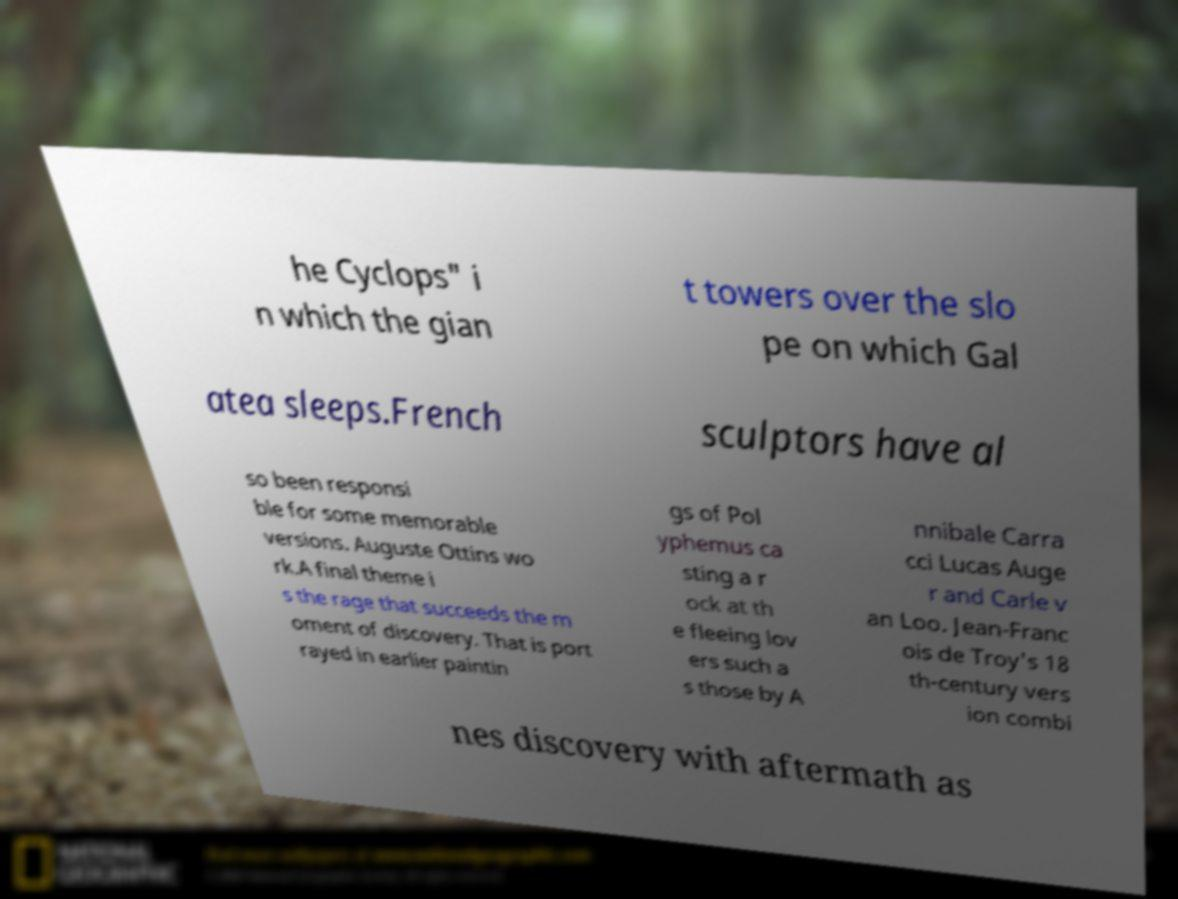Can you accurately transcribe the text from the provided image for me? he Cyclops" i n which the gian t towers over the slo pe on which Gal atea sleeps.French sculptors have al so been responsi ble for some memorable versions. Auguste Ottins wo rk.A final theme i s the rage that succeeds the m oment of discovery. That is port rayed in earlier paintin gs of Pol yphemus ca sting a r ock at th e fleeing lov ers such a s those by A nnibale Carra cci Lucas Auge r and Carle v an Loo. Jean-Franc ois de Troy's 18 th-century vers ion combi nes discovery with aftermath as 